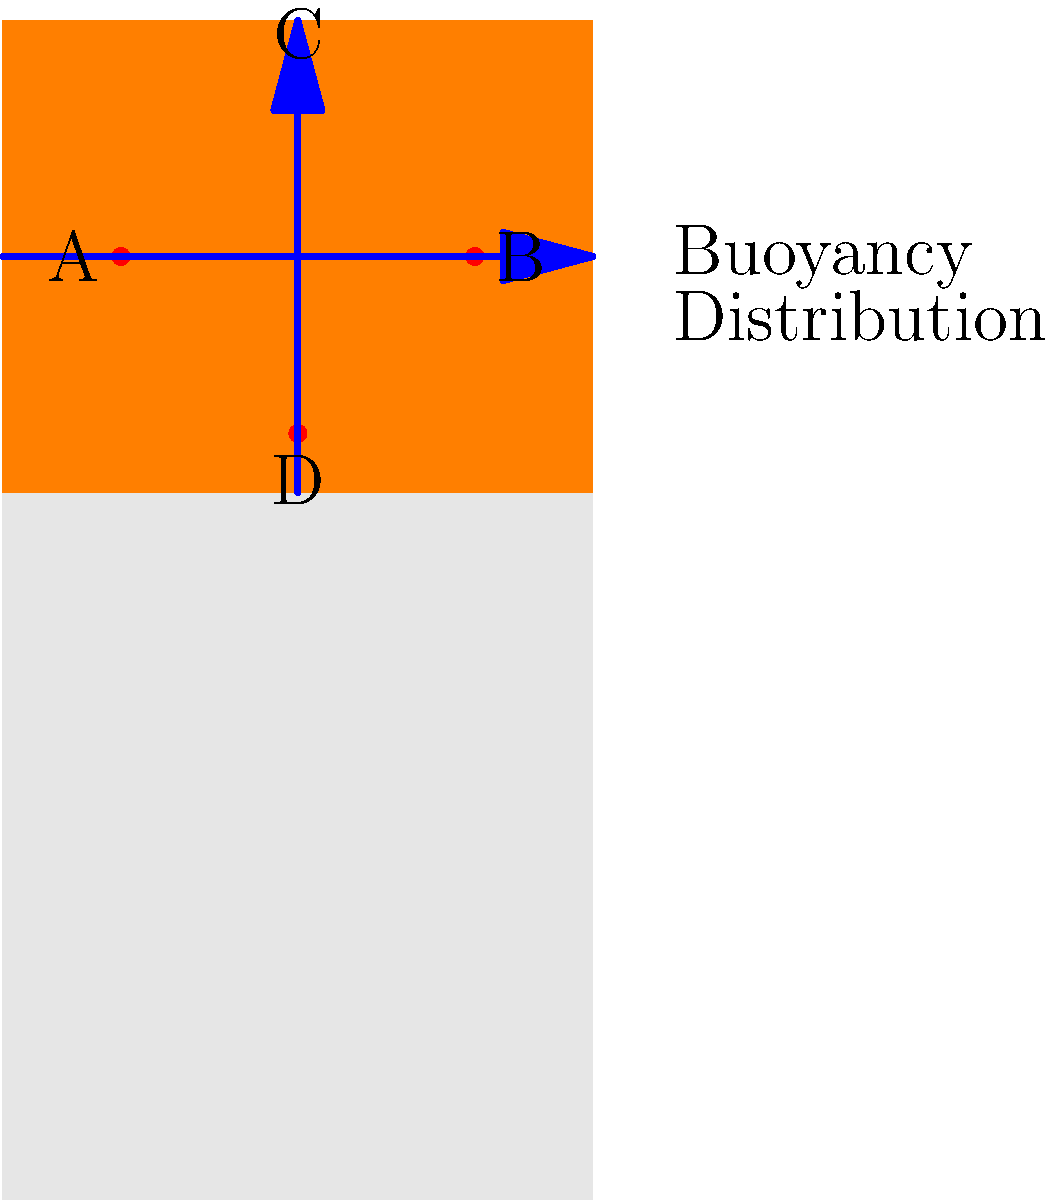As a boating enthusiast concerned with family safety, you're evaluating life jacket designs. The diagram shows pressure points (A, B, C, D) and buoyancy distribution of a life jacket. Which pressure point is most critical for ensuring proper fit and preventing the jacket from riding up when in water, potentially compromising its effectiveness? To determine the most critical pressure point for ensuring proper fit and preventing the life jacket from riding up, let's analyze each point:

1. Point A: Located on the left side of the chest. While important for fit, it's not the primary point preventing upward movement.

2. Point B: Located on the right side of the chest. Similar to point A, it's important for fit but not crucial for preventing upward movement.

3. Point C: Located at the top of the chest/neck area. This point helps keep the life jacket in place but doesn't directly prevent it from riding up.

4. Point D: Located at the bottom of the life jacket, near the waist. This is the most critical point for several reasons:
   a) It's the lowest point, acting as an anchor for the entire jacket.
   b) It prevents the jacket from riding up when the wearer is in water.
   c) It ensures that the buoyancy is distributed correctly, keeping the wearer's head above water.

The buoyancy distribution arrows in the diagram show that the upward force is strongest at the chest level. Without a secure fit at point D, this upward force could cause the jacket to shift position, potentially compromising its effectiveness in keeping the wearer's head above water.

Therefore, point D is the most critical pressure point for ensuring proper fit and preventing the life jacket from riding up in water.
Answer: Point D (waist level) 